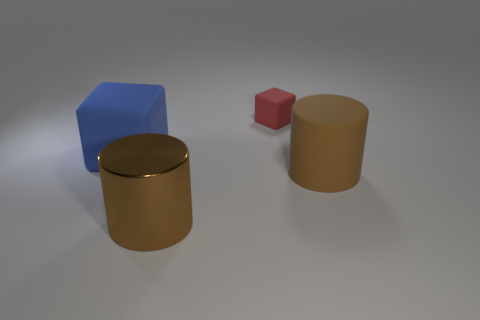There is another cylinder that is the same color as the matte cylinder; what is its material?
Give a very brief answer. Metal. There is a object that is both to the right of the large brown metal cylinder and in front of the large blue rubber block; what is its size?
Ensure brevity in your answer.  Large. How many metal things are either brown objects or big blocks?
Provide a short and direct response. 1. Are there more blue things on the left side of the big rubber cube than rubber cylinders?
Your response must be concise. No. There is a block that is behind the big blue cube; what is it made of?
Offer a very short reply. Rubber. What number of tiny red cubes have the same material as the blue block?
Your answer should be very brief. 1. What shape is the object that is left of the tiny red cube and behind the metal thing?
Your answer should be compact. Cube. What number of things are either big brown objects that are to the left of the big brown rubber thing or big objects that are to the left of the brown shiny object?
Offer a very short reply. 2. Is the number of brown matte cylinders that are in front of the brown shiny object the same as the number of large rubber objects that are behind the large brown matte cylinder?
Your response must be concise. No. There is a large thing that is in front of the brown thing that is to the right of the red rubber object; what is its shape?
Your answer should be very brief. Cylinder. 